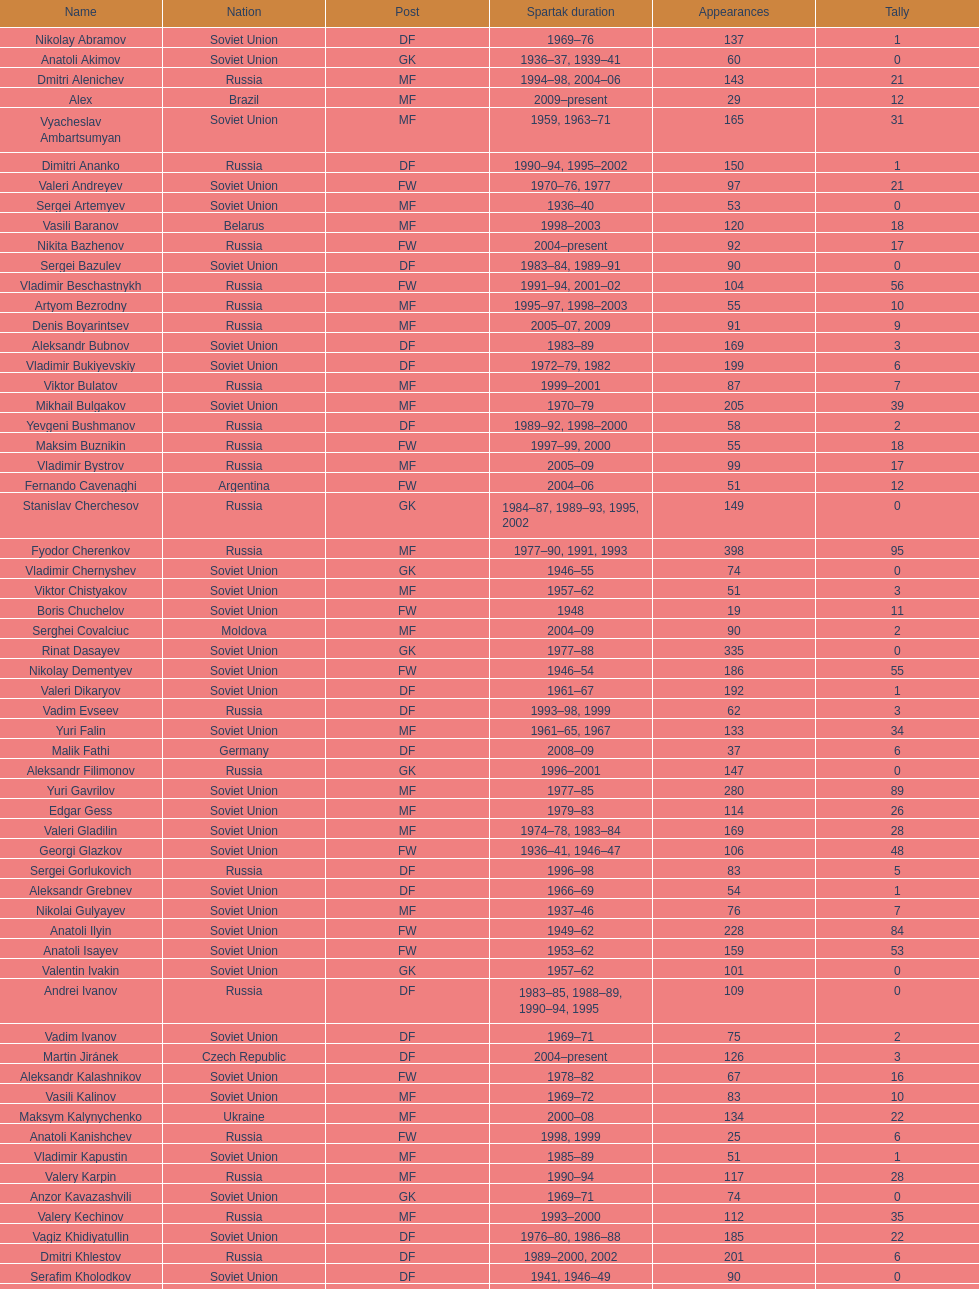How many players had at least 20 league goals scored? 56. 